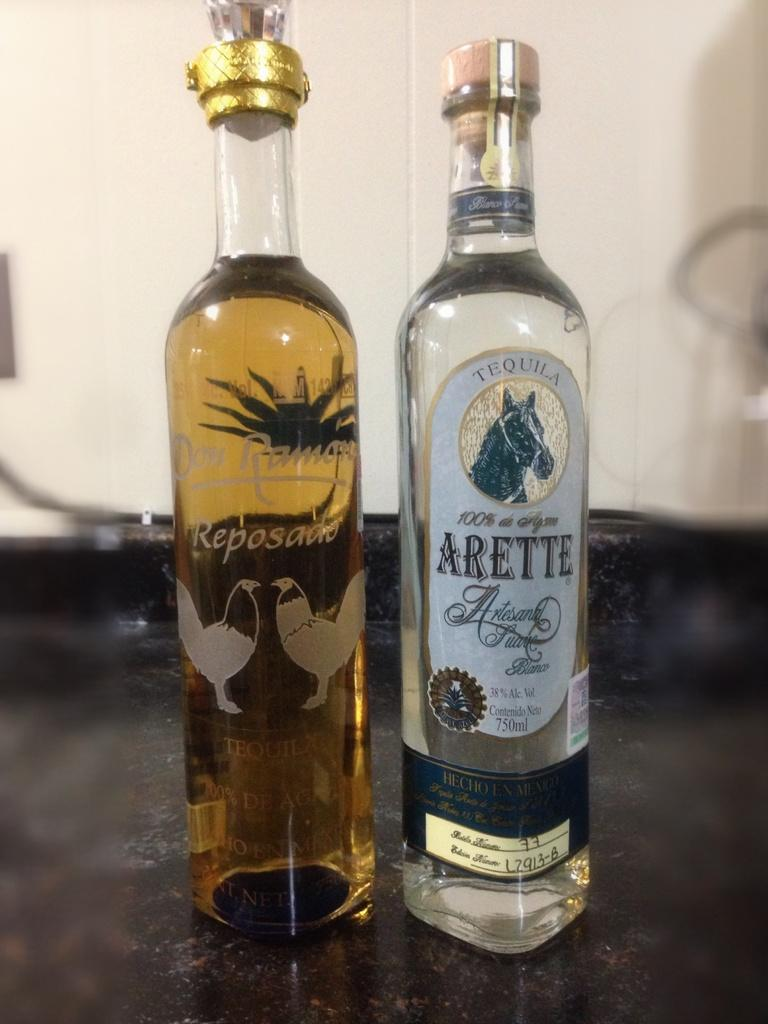Provide a one-sentence caption for the provided image. Two tall bottles are side by side, one filled with tequila and each with animals etched on the bottles. 